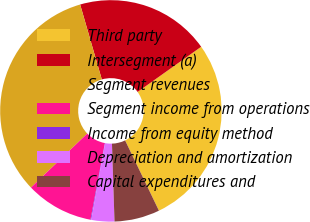<chart> <loc_0><loc_0><loc_500><loc_500><pie_chart><fcel>Third party<fcel>Intersegment (a)<fcel>Segment revenues<fcel>Segment income from operations<fcel>Income from equity method<fcel>Depreciation and amortization<fcel>Capital expenditures and<nl><fcel>27.69%<fcel>19.65%<fcel>32.69%<fcel>9.88%<fcel>0.11%<fcel>3.36%<fcel>6.62%<nl></chart> 